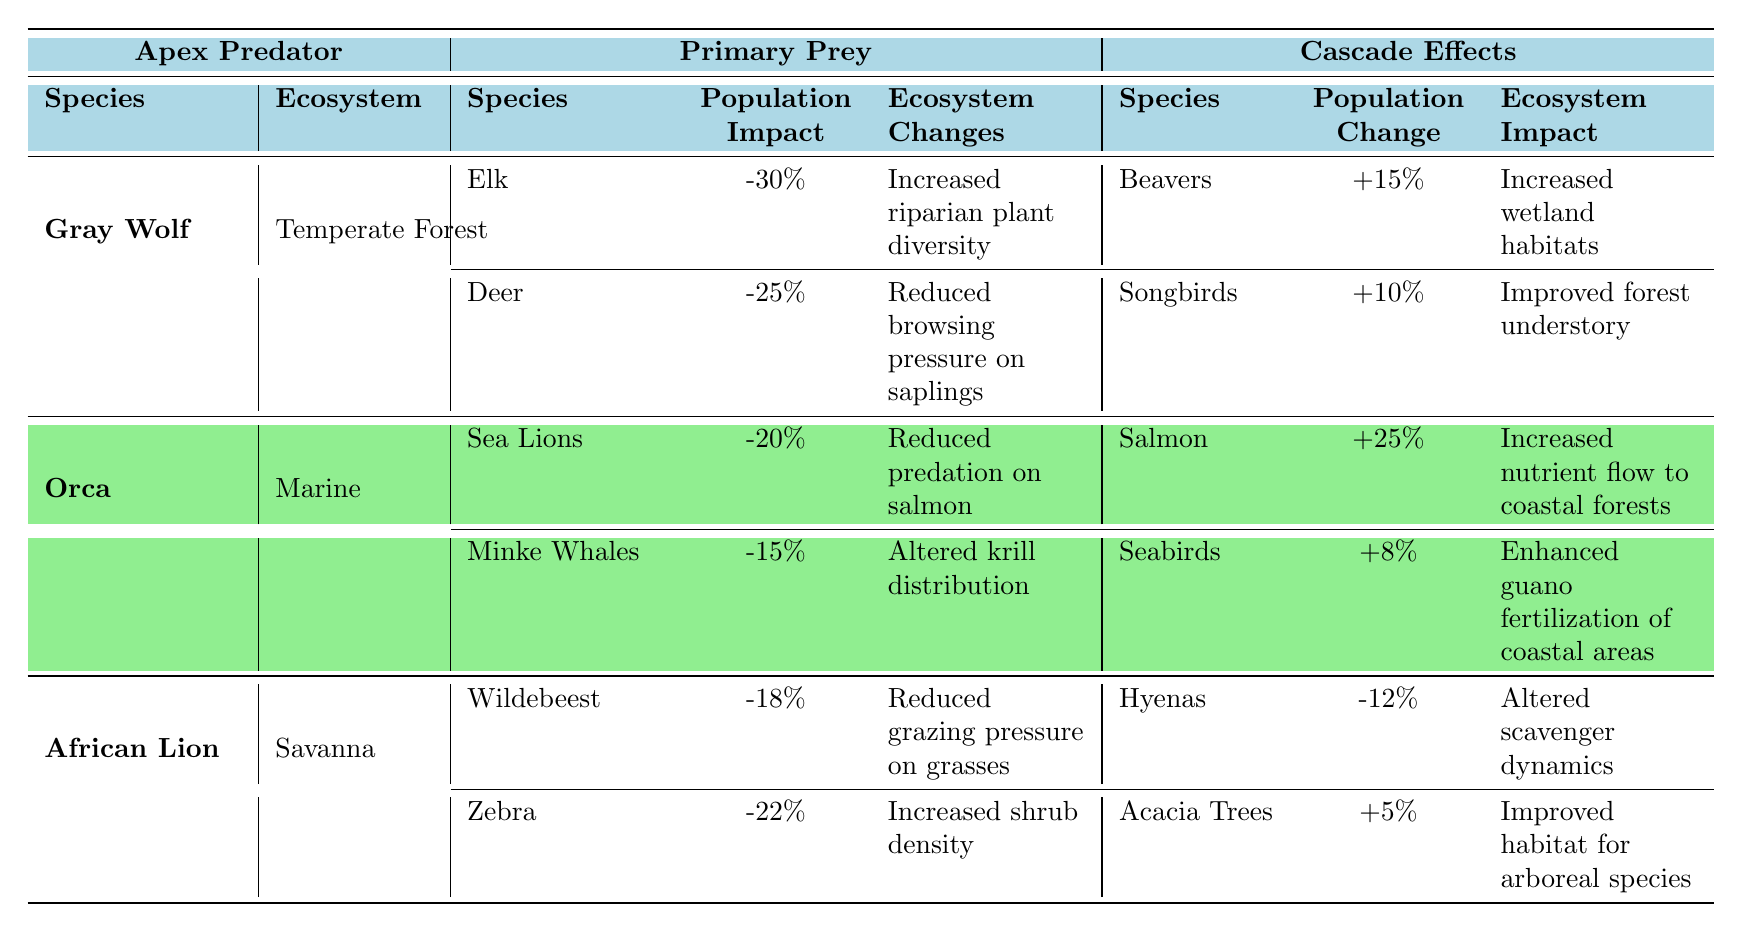What is the population impact of Gray Wolf's primary prey, Elk? The table indicates that the population impact of Elk, which is a primary prey of the Gray Wolf, is -30%.
Answer: -30% How many species of primary prey does the African Lion have? The table shows that the African Lion has two primary prey species listed: Wildebeest and Zebra.
Answer: 2 What is the ecosystem impact associated with the population change of Salmon due to Orcas? Orcas have a positive population change effect on Salmon, which contributes to increased nutrient flow to coastal forests.
Answer: Increased nutrient flow to coastal forests What is the total population impact on primary prey for the Gray Wolf? To find the total population impact, sum the impacts of Elk (-30%) and Deer (-25%), resulting in -30% + (-25%) = -55%.
Answer: -55% Is the population impact of Orcas on Minke Whales greater than that on Sea Lions? The population impact of Minke Whales is -15%, while that of Sea Lions is -20%. Therefore, -15% is greater than -20%.
Answer: Yes What effect does the population change of Beavers have on the ecosystem in the Temperate Forest? The table states that the population change of Beavers is +15%, which leads to increased wetland habitats.
Answer: Increased wetland habitats Which apex predator has the greatest positive change in population for its cascade effects? The Orcas show a +25% change in population for Salmon, which is the highest among cascade effects listed for the apex predators.
Answer: Orca What overall trend can be inferred about the vegetation changes in the ecosystems with Gray Wolves and African Lions present? Gray Wolves are associated with increased plant diversity and reduced browsing pressure on saplings, while African Lions lead to reduced grazing pressure on grasses and increased shrub density; both actions generally promote vegetation health.
Answer: Positive vegetation trend What is the ecosystem impact of Acacia Trees due to the African Lion's cascade effect? The table indicates a +5% population change for Acacia Trees, which results in improved habitat for arboreal species.
Answer: Improved habitat for arboreal species 